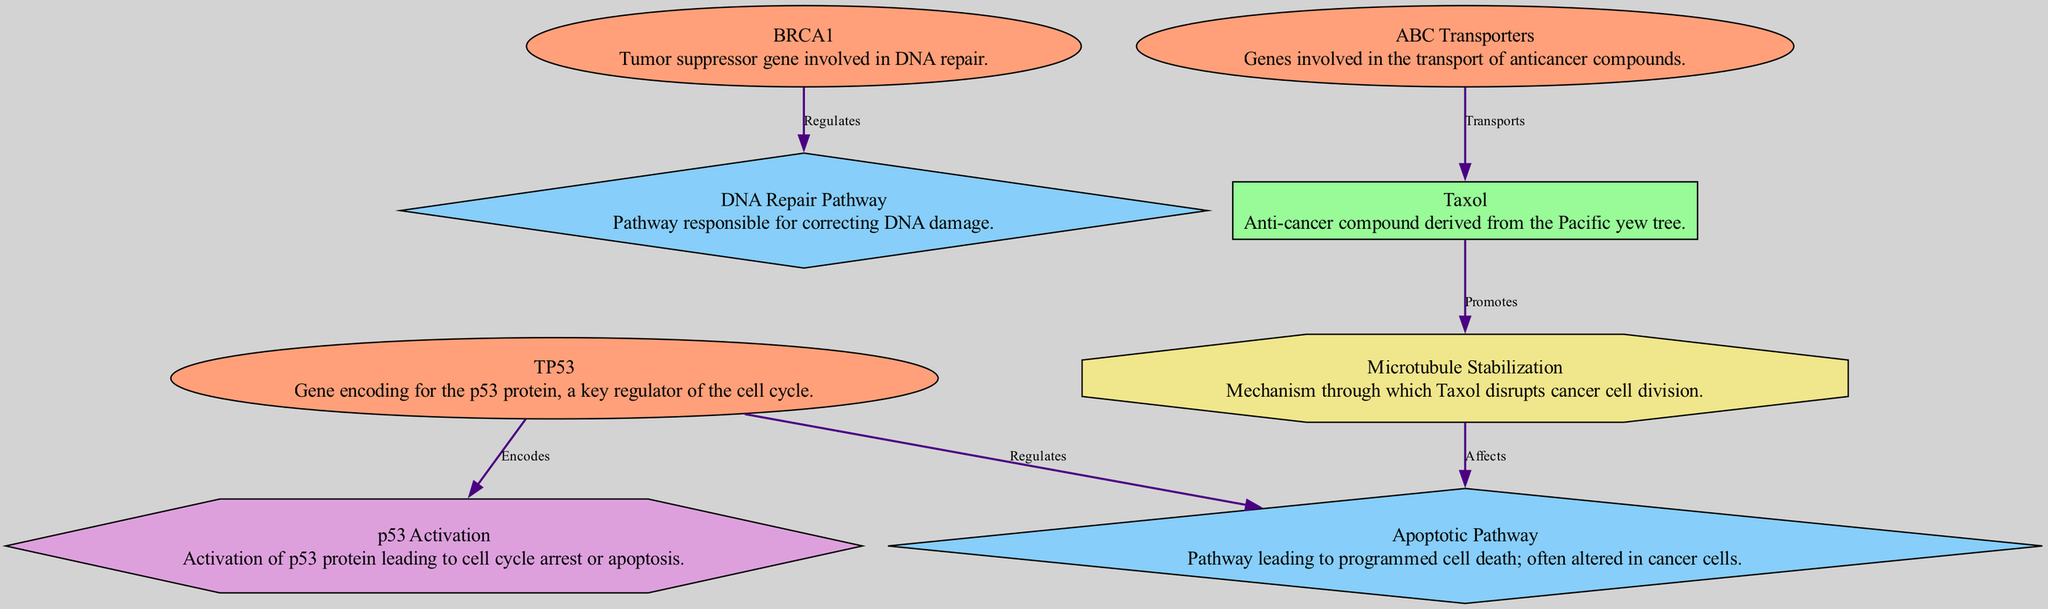What are the two genes that regulate the apoptotic pathway? From the diagram, we see the 'Apoptotic Pathway' is regulated by 'TP53'. The edges indicate that 'TP53' has a direct regulating connection to this pathway. Thus, the answer is 'TP53'.
Answer: TP53 How many nodes are represented in the diagram? By counting, we can see that there are 8 nodes listed in the diagram. This includes genes, compounds, pathways, and mechanisms.
Answer: 8 What compound is transported by ABC Transporters? The diagram shows that 'ABC Transporters' has a direct edge labeled 'Transports' leading to 'Taxol'. Hence, the compound being referred to is 'Taxol'.
Answer: Taxol What is the role of the BRCA1 gene in DNA repair? The diagram shows an edge from 'BRCA1' to the 'DNA Repair Pathway' labeled 'Regulates'. This indicates that 'BRCA1' plays a regulatory role in facilitating the DNA repair process.
Answer: Regulates Which mechanism affects the apoptotic pathway? The diagram indicates that 'Microtubule Stabilization', which is a mechanism, has an edge 'Affects' leading to the 'Apoptotic Pathway'. This shows a direct influence on this pathway.
Answer: Microtubule Stabilization How does Taxol influence cancer cell division? The diagram states that 'Taxol' promotes 'Microtubule Stabilization', and this mechanism subsequently affects the 'Apoptotic Pathway'. Therefore, it disrupts cancer cell division through stabilization of microtubules leading to apoptosis.
Answer: Disrupts cancer cell division What is the interaction facilitated by TP53? The interaction denoted by 'TP53' has an edge labeled 'Encodes' leading to 'p53 Activation', indicating that it facilitates this specific interaction. Therefore, the interaction concerned is 'p53 Activation'.
Answer: p53 Activation Which node demonstrates the gene responsible for transporting anticancer compounds? The node labeled 'ABC Transporters' specifically indicates it involves genes that transport anticancer compounds as shown in the diagram.
Answer: ABC Transporters What is the function of the compound Taxol based on its description? The diagram describes 'Taxol' as an anti-cancer compound. Thus, its primary function as per the diagram is to combat cancer.
Answer: Anti-cancer compound 